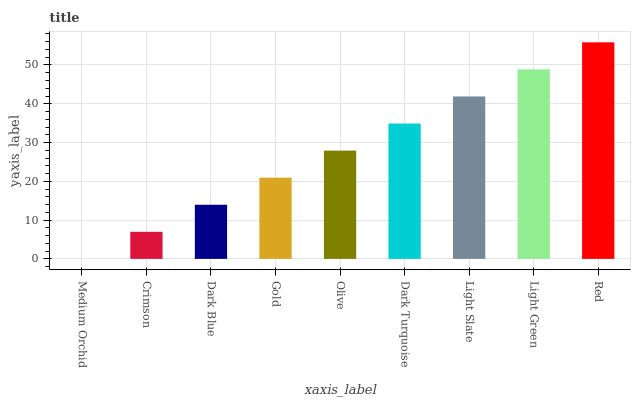Is Medium Orchid the minimum?
Answer yes or no. Yes. Is Red the maximum?
Answer yes or no. Yes. Is Crimson the minimum?
Answer yes or no. No. Is Crimson the maximum?
Answer yes or no. No. Is Crimson greater than Medium Orchid?
Answer yes or no. Yes. Is Medium Orchid less than Crimson?
Answer yes or no. Yes. Is Medium Orchid greater than Crimson?
Answer yes or no. No. Is Crimson less than Medium Orchid?
Answer yes or no. No. Is Olive the high median?
Answer yes or no. Yes. Is Olive the low median?
Answer yes or no. Yes. Is Light Slate the high median?
Answer yes or no. No. Is Gold the low median?
Answer yes or no. No. 